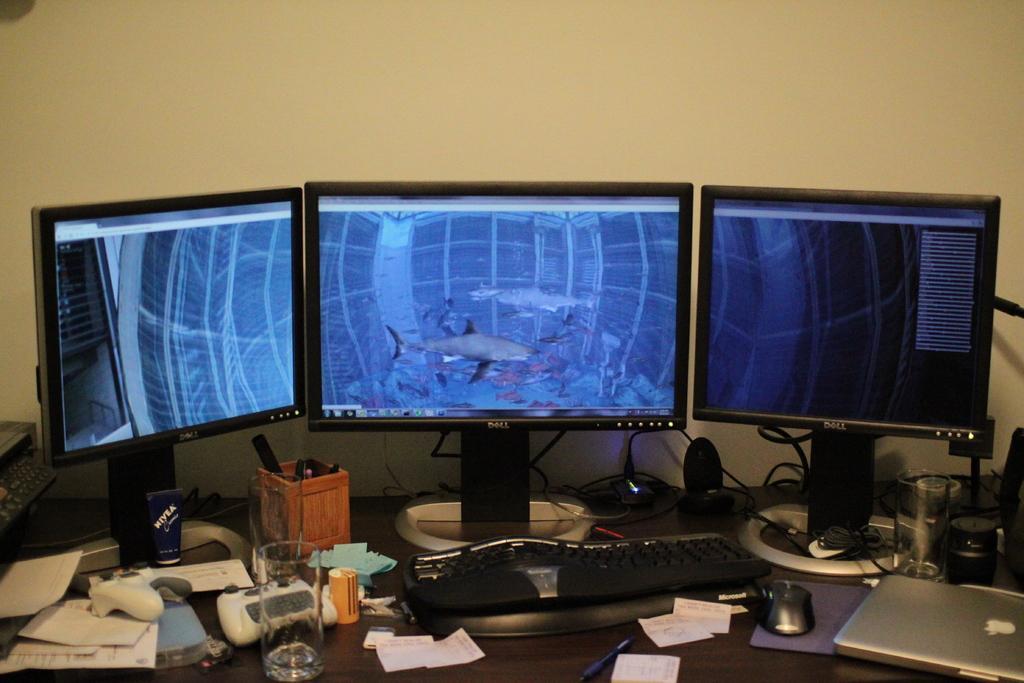In one or two sentences, can you explain what this image depicts? This image consists of a table. On that table there are computers. There are laptop, keyboard, mouse, papers, pens, glasses, speakers, wires. 